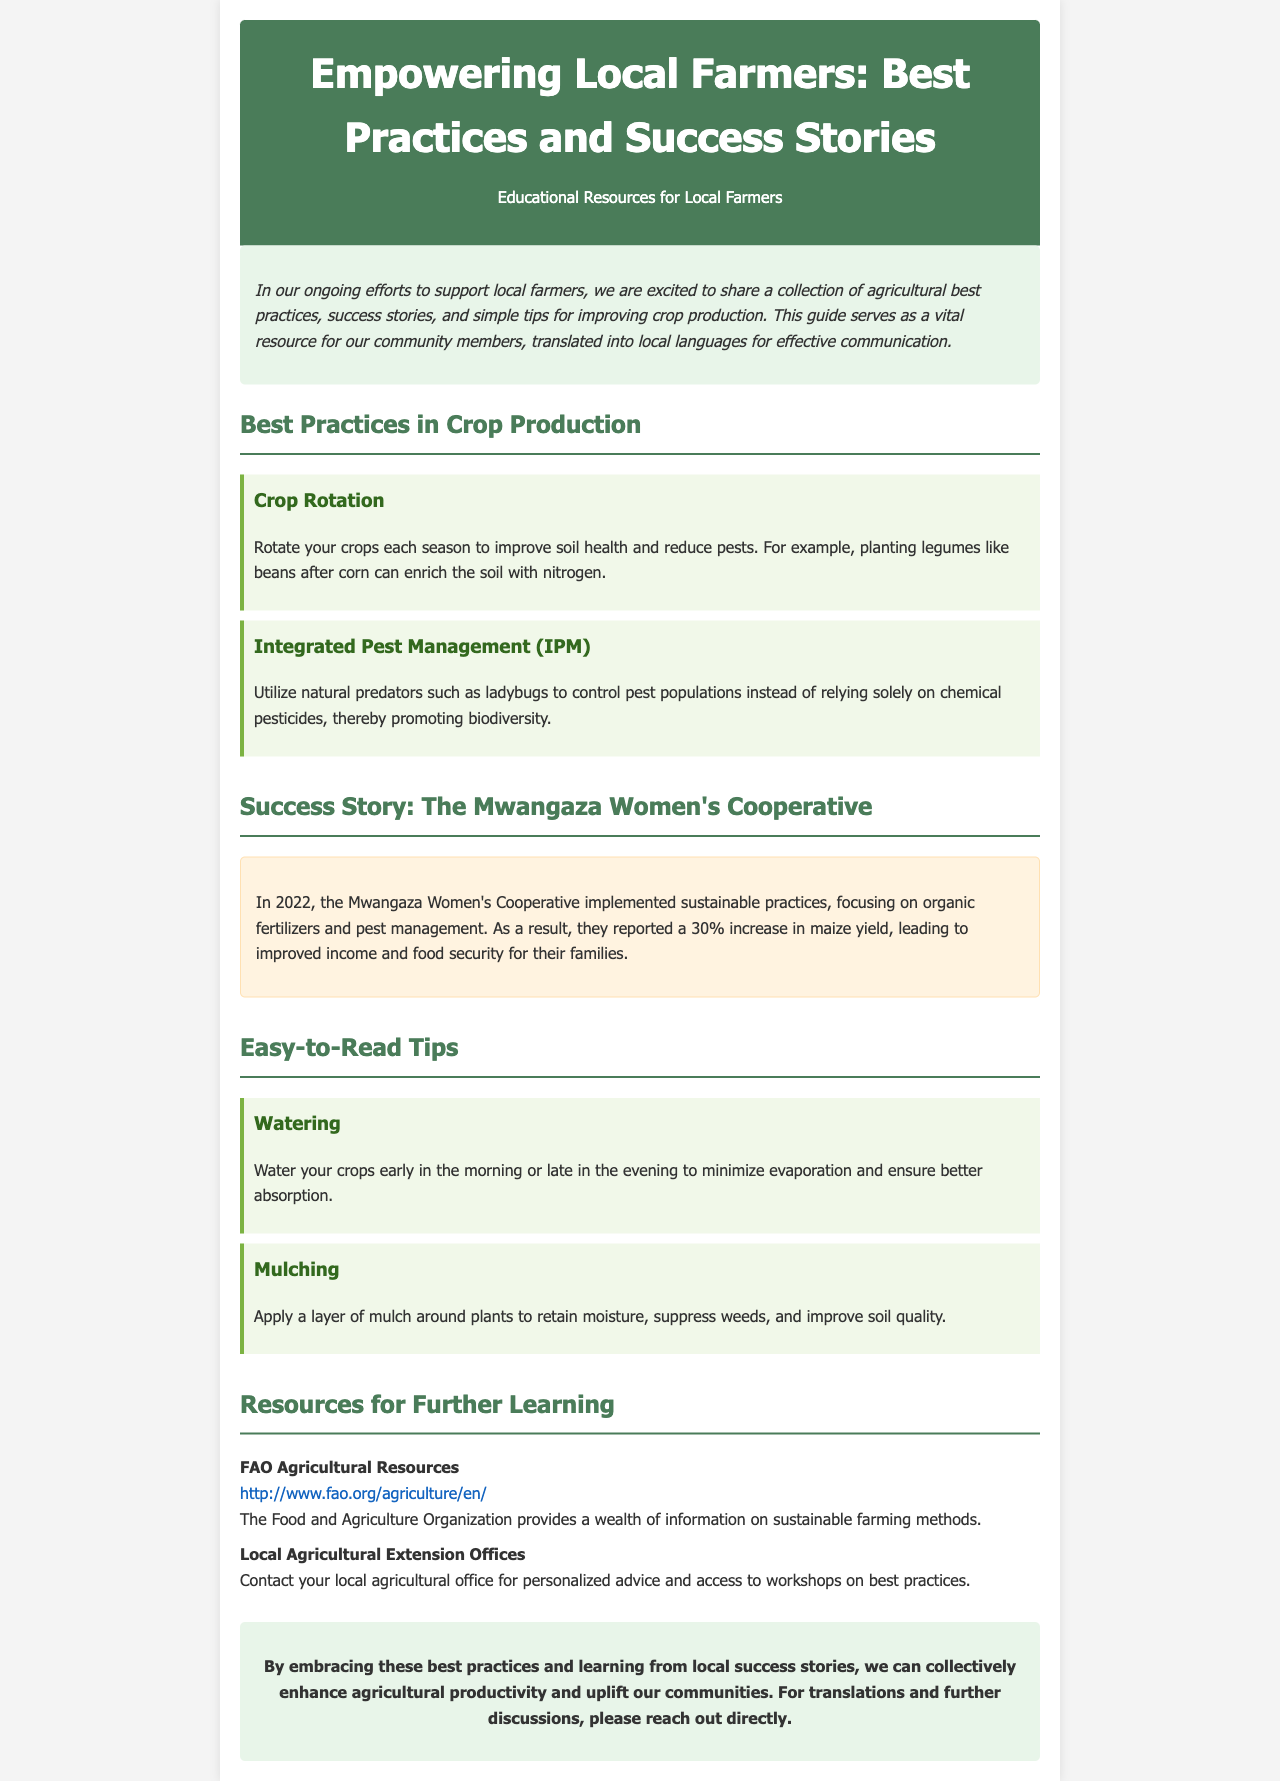what is the title of the newsletter? The title of the newsletter appears at the top header section.
Answer: Empowering Local Farmers: Best Practices and Success Stories what year did the Mwangaza Women's Cooperative report an increase in maize yield? The year is specifically mentioned in the success story section of the document.
Answer: 2022 what is one method of pest management mentioned in the best practices? The document lists specific methods in the best practices section.
Answer: Integrated Pest Management what percentage increase in maize yield did the Mwangaza Women's Cooperative achieve? This information is provided in the success story section as a measure of their success with their practices.
Answer: 30% what type of resource is linked to in the document? The document provides links to external resources for further learning.
Answer: FAO Agricultural Resources what is one tip for watering crops? The easy-to-read tips section provides practical advice for crop care.
Answer: Early in the morning or late in the evening how many sections are there in the newsletter? By counting the distinct sections in the document, we can determine the total number of sections.
Answer: Four 